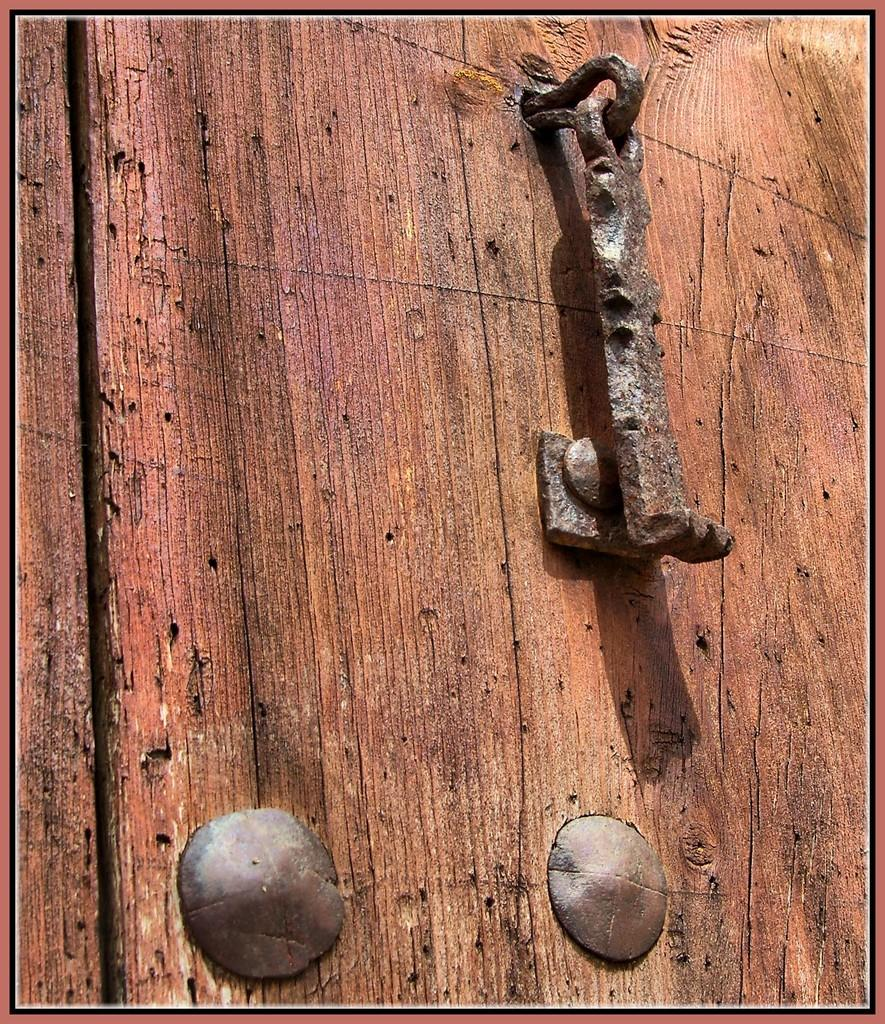What is the main object in the image? There is a door in the image. Can you describe any features of the door? There is a metallic object on the door that looks like a door lock. How many stems can be seen growing from the door in the image? There are no stems growing from the door in the image. What type of cub is visible on the door in the image? There is no cub present on the door in the image. 